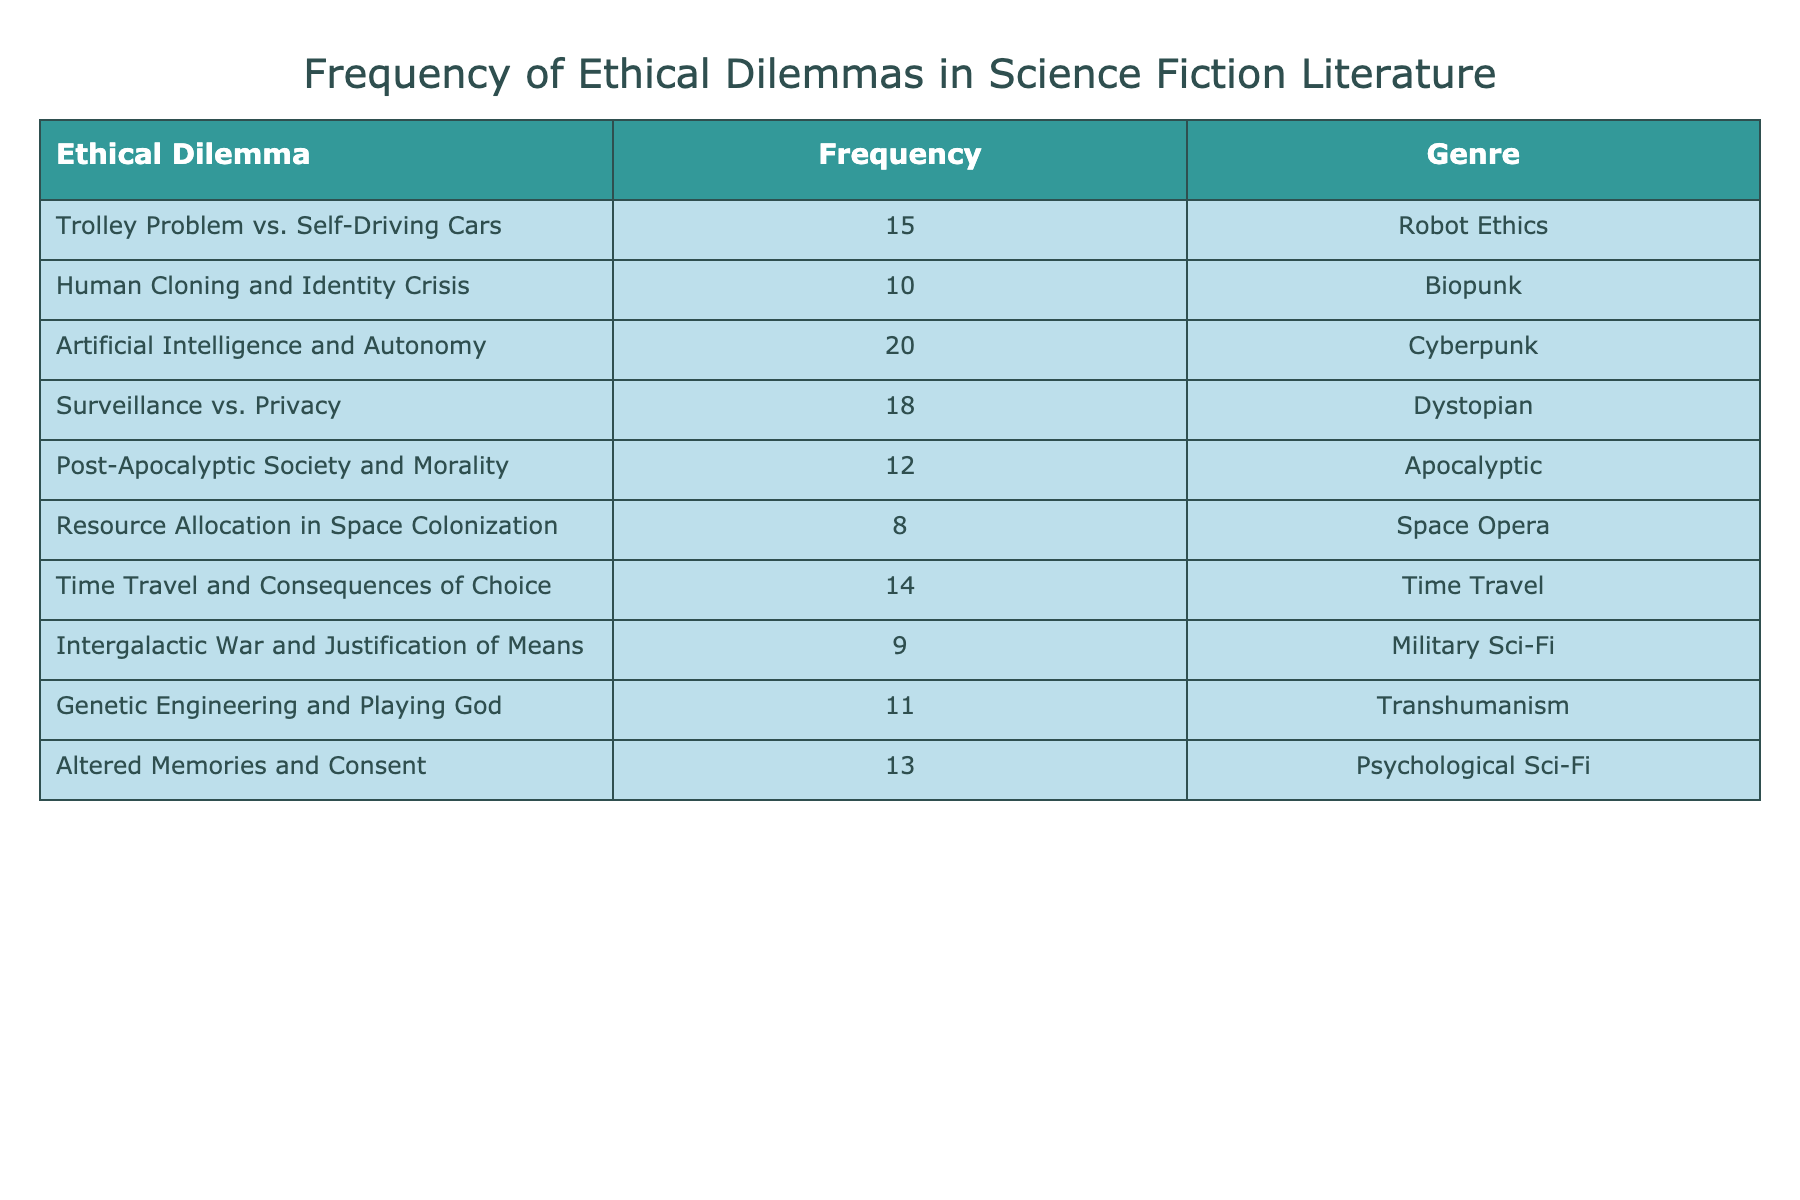What is the frequency of the "Trolley Problem vs. Self-Driving Cars" dilemma? The table shows that "Trolley Problem vs. Self-Driving Cars" has a frequency of 15.
Answer: 15 Which ethical dilemma appears most frequently in the data? The dilemma with the highest frequency is "Artificial Intelligence and Autonomy," with a frequency of 20.
Answer: Artificial Intelligence and Autonomy What is the total frequency of dilemmas in the "Dystopian" genre? The frequency of dilemmas in the "Dystopian" genre is 18 for "Surveillance vs. Privacy." Therefore, the total frequency for this genre is 18.
Answer: 18 Is "Genetic Engineering and Playing God" more frequent than "Intergalactic War and Justification of Means"? The frequency of "Genetic Engineering and Playing God" is 11, while "Intergalactic War and Justification of Means" is 9. Since 11 is greater than 9, the statement is true.
Answer: Yes What is the average frequency of dilemmas across all genres? To find the average frequency, we sum all frequencies (15 + 10 + 20 + 18 + 12 + 8 + 14 + 9 + 11 + 13 =  136) and divide by the number of dilemmas (10). Thus, the average frequency is 136/10 = 13.6.
Answer: 13.6 How many dilemmas have a frequency greater than 12? The dilemmas with frequencies greater than 12 are "Artificial Intelligence and Autonomy" (20), "Surveillance vs. Privacy" (18), "Trolley Problem vs. Self-Driving Cars" (15), "Time Travel and Consequences of Choice" (14), and "Altered Memories and Consent" (13). There are 5 dilemmas in total that meet this criterion.
Answer: 5 Which genre has the least frequency of ethical dilemmas presented? The genre with the least frequency is "Space Opera," with a frequency of 8 for "Resource Allocation in Space Colonization."
Answer: Space Opera What is the frequency difference between "Human Cloning and Identity Crisis" and "Post-Apocalyptic Society and Morality"? The frequency of "Human Cloning and Identity Crisis" is 10, and that of "Post-Apocalyptic Society and Morality" is 12. The difference is 12 - 10 = 2.
Answer: 2 Are there any dilemmas in the "Biopunk" genre? Yes, there is one dilemma in the "Biopunk" genre, which is "Human Cloning and Identity Crisis" with a frequency of 10.
Answer: Yes 